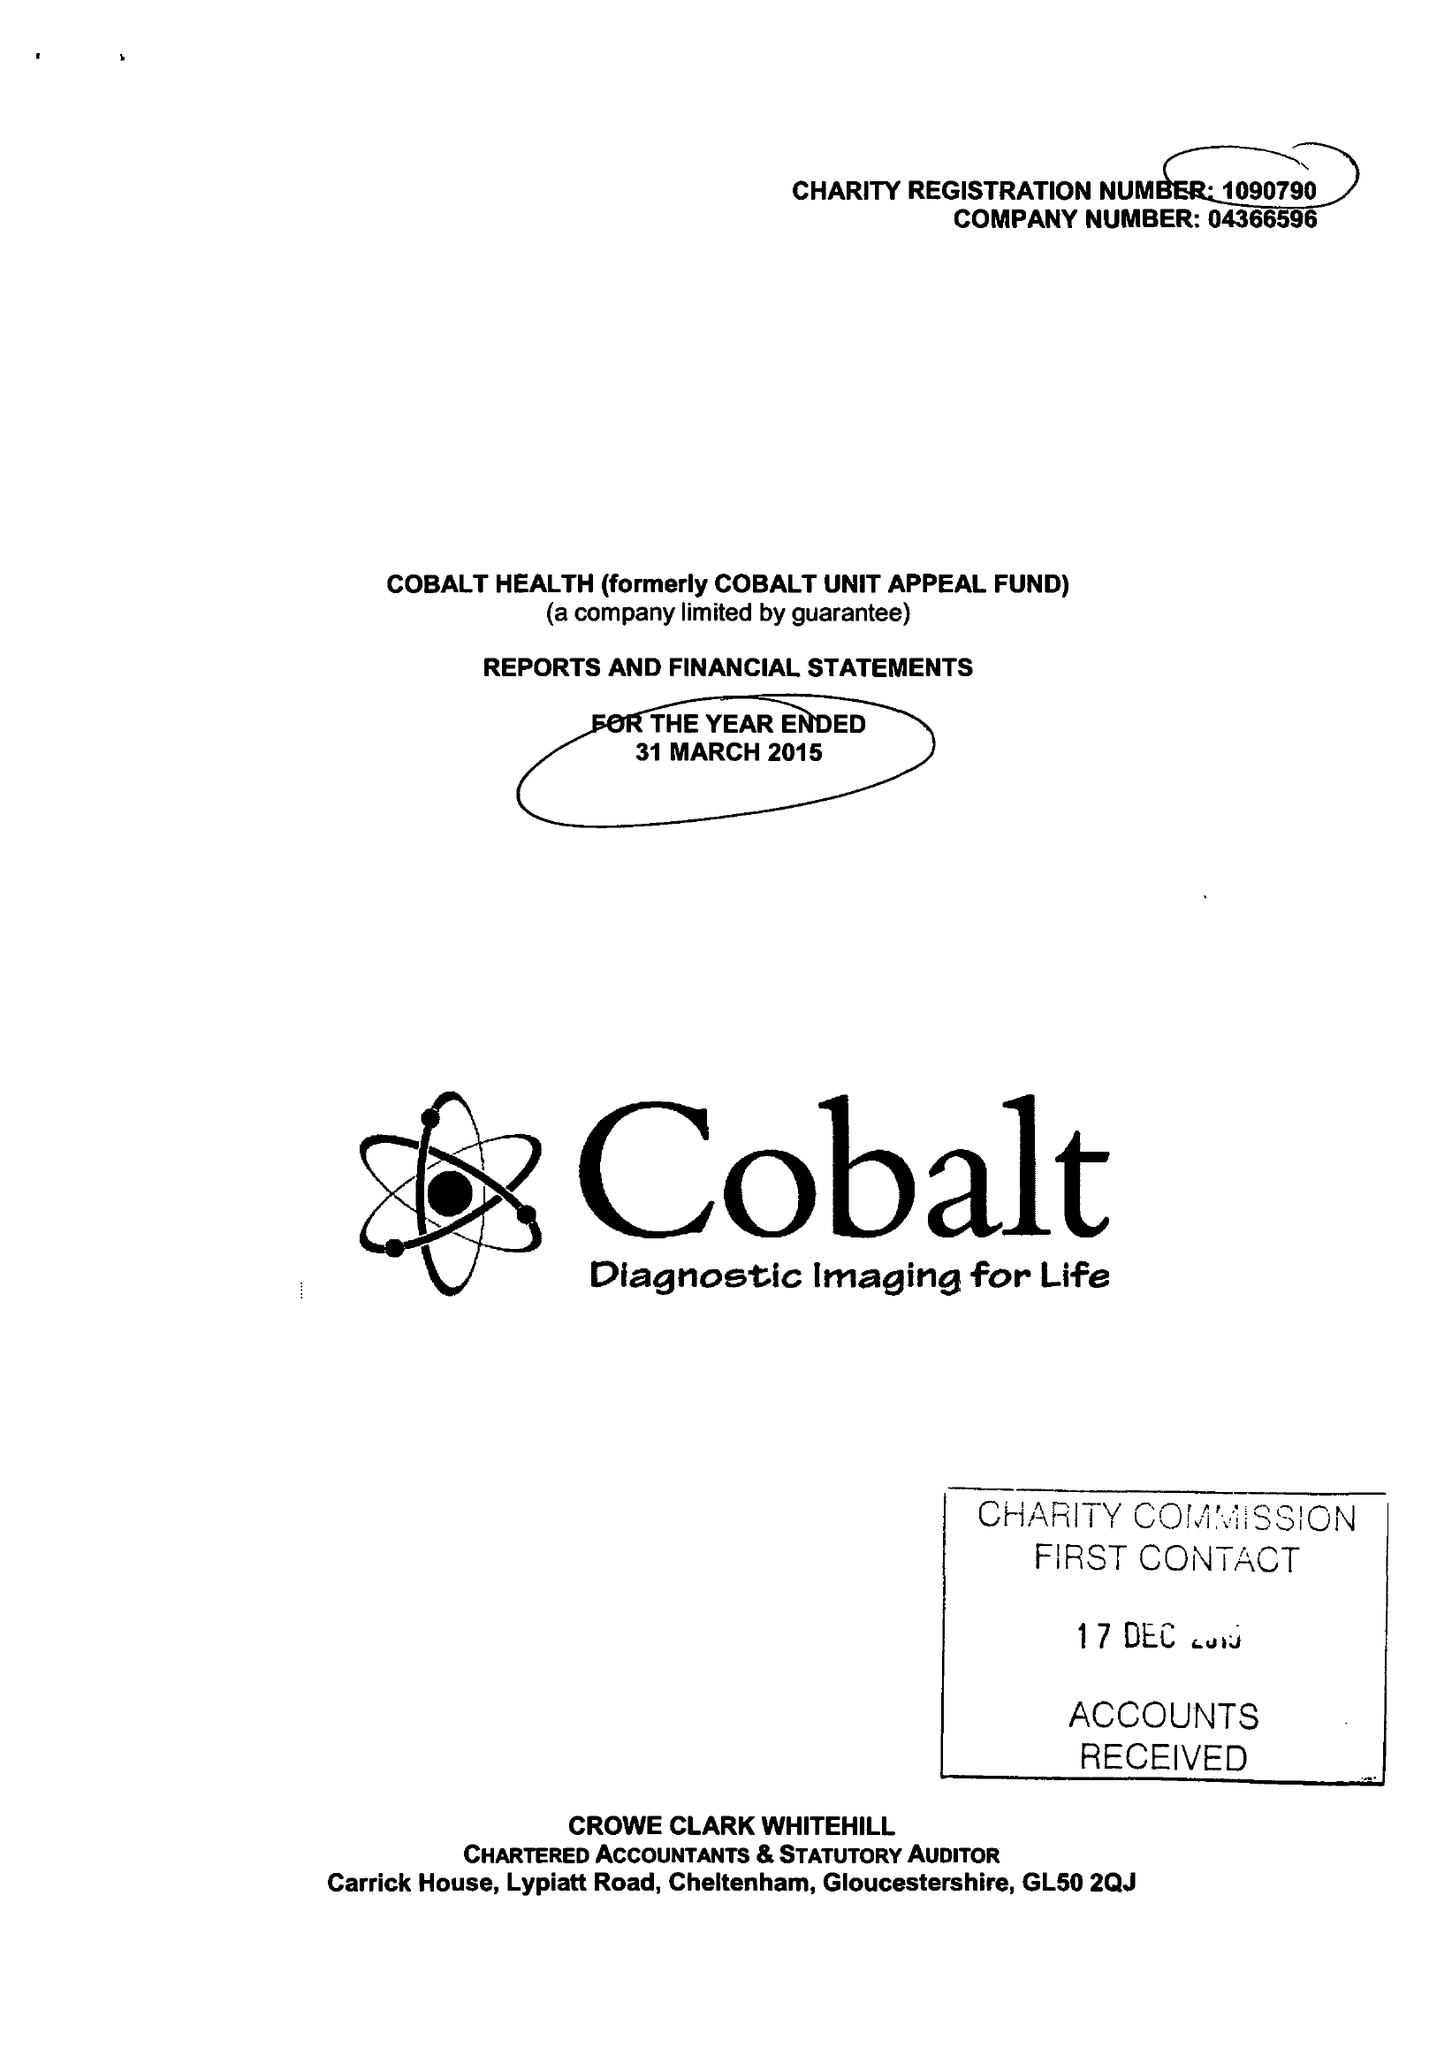What is the value for the charity_name?
Answer the question using a single word or phrase. Cobalt Health 